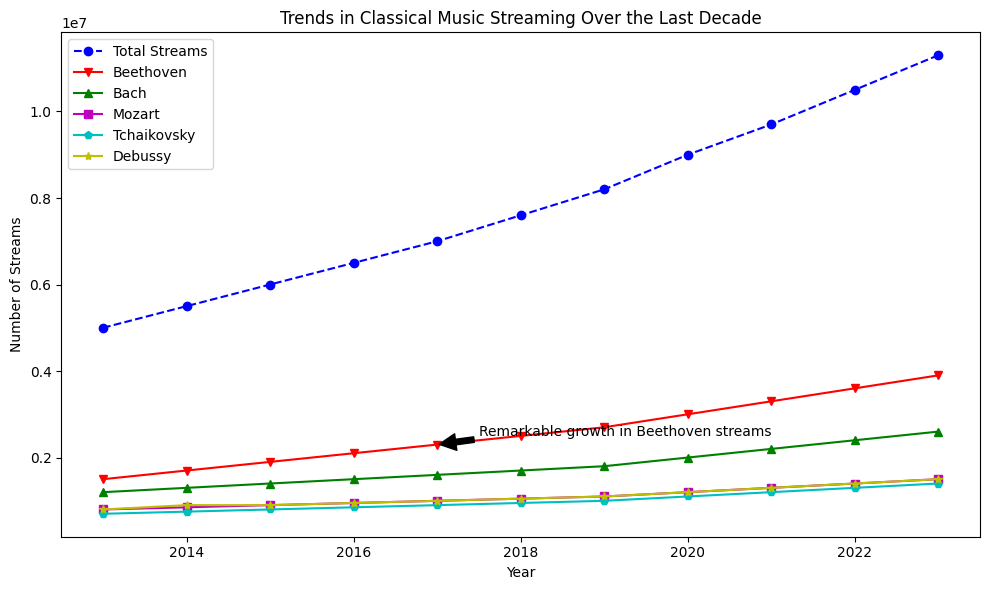Which composer had the highest number of streams in 2020? Look at the values for each composer for the year 2020. Compare the streams: Beethoven (3,000,000), Bach (2,000,000), Mozart (1,200,000), Tchaikovsky (1,100,000), Debussy (1,200,000). Beethoven has the highest number of streams.
Answer: Beethoven Which year saw the notable growth in Beethoven streams according to the annotation? Identify the year with a specific annotation. The annotation "Remarkable growth in Beethoven streams" points to 2017.
Answer: 2017 What is the total number of streams for Debussy and Mozart combined in 2023? Add the streams for Debussy (1,500,000) and Mozart (1,400,000) in 2023: 1,500,000 + 1,400,000 = 2,900,000.
Answer: 2,900,000 How did the total number of streams change from 2013 to 2023? Subtract the total number of streams in 2013 (5,000,000) from the total in 2023 (11,300,000): 11,300,000 - 5,000,000 = 6,300,000.
Answer: Increased by 6,300,000 Which composer's streams saw the least growth from 2015 to 2023? Calculate the difference for each composer between 2015 and 2023: Beethoven (3,900,000 - 1,900,000 = 2,000,000), Bach (2,600,000 - 1,400,000 = 1,200,000), Mozart (1,500,000 - 900,000 = 600,000), Tchaikovsky (1,400,000 - 800,000 = 600,000), Debussy (1,500,000 - 900,000 = 600,000). Mozart, Tchaikovsky, and Debussy all saw the least growth (600,000).
Answer: Mozart, Tchaikovsky, Debussy What is the average number of streams for Tchaikovsky from 2019 to 2023? Sum Tchaikovsky's streams from 2019 to 2023: 1,000,000 + 1,100,000 + 1,200,000 + 1,300,000 + 1,400,000 = 6,000,000. Divide by the number of years (5): 6,000,000 / 5 = 1,200,000.
Answer: 1,200,000 Which composer had the greatest increase in streams from 2018 to 2020? Calculate the difference for each composer between 2018 and 2020: Beethoven (3,000,000 - 2,500,000 = 500,000), Bach (2,000,000 - 1,700,000 = 300,000), Mozart (1,200,000 - 1,050,000 = 150,000), Tchaikovsky (1,100,000 - 950,000 = 150,000), Debussy (1,200,000 - 1,050,000 = 150,000). Beethoven had the greatest increase of 500,000.
Answer: Beethoven Between Bach and Beethoven, who had a steeper growth in streams from 2013 to 2023? Calculate the growth for Bach: 2023 streams (2,600,000) - 2013 streams (1,200,000) = 1,400,000. Calculate the growth for Beethoven: 2023 streams (3,900,000) - 2013 streams (1,500,000) = 2,400,000. Beethoven had steeper growth.
Answer: Beethoven During which year did the total streams cross 9,000,000? Identify the year when the total streams first exceeded 9,000,000. In 2020, total streams were 9,000,000.
Answer: 2020 What is the difference in streams between Bach and Tchaikovsky in 2022? Subtract Tchaikovsky's streams from Bach's streams in 2022: 2,400,000 - 1,300,000 = 1,100,000.
Answer: 1,100,000 